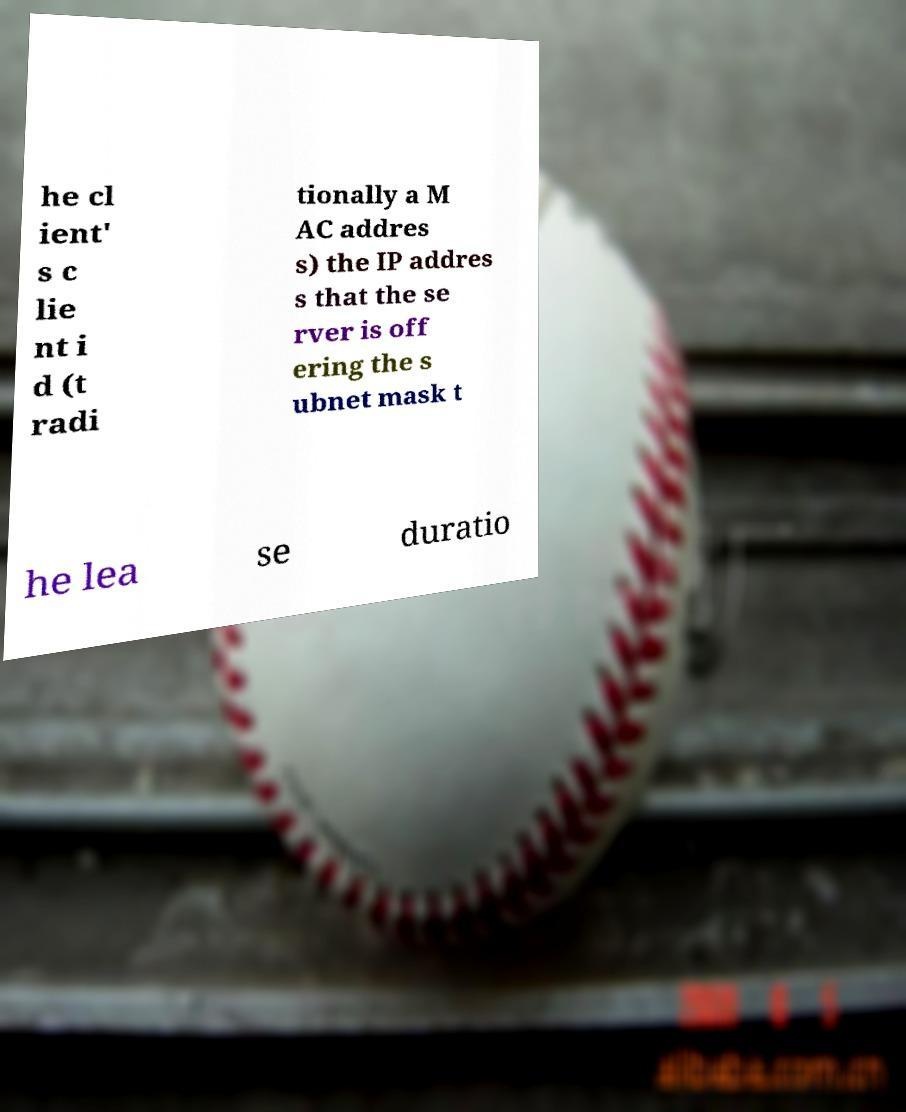Can you accurately transcribe the text from the provided image for me? he cl ient' s c lie nt i d (t radi tionally a M AC addres s) the IP addres s that the se rver is off ering the s ubnet mask t he lea se duratio 